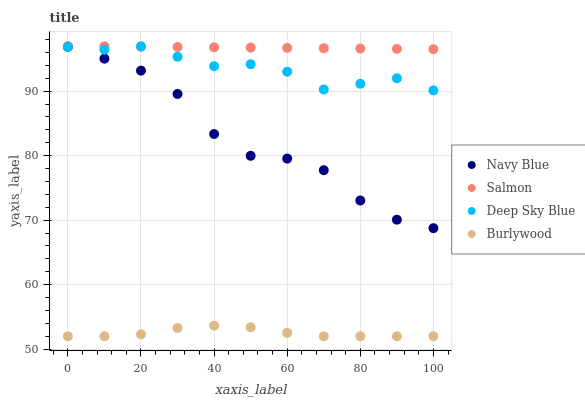Does Burlywood have the minimum area under the curve?
Answer yes or no. Yes. Does Salmon have the maximum area under the curve?
Answer yes or no. Yes. Does Navy Blue have the minimum area under the curve?
Answer yes or no. No. Does Navy Blue have the maximum area under the curve?
Answer yes or no. No. Is Salmon the smoothest?
Answer yes or no. Yes. Is Navy Blue the roughest?
Answer yes or no. Yes. Is Navy Blue the smoothest?
Answer yes or no. No. Is Salmon the roughest?
Answer yes or no. No. Does Burlywood have the lowest value?
Answer yes or no. Yes. Does Navy Blue have the lowest value?
Answer yes or no. No. Does Salmon have the highest value?
Answer yes or no. Yes. Does Navy Blue have the highest value?
Answer yes or no. No. Is Burlywood less than Deep Sky Blue?
Answer yes or no. Yes. Is Navy Blue greater than Burlywood?
Answer yes or no. Yes. Does Navy Blue intersect Deep Sky Blue?
Answer yes or no. Yes. Is Navy Blue less than Deep Sky Blue?
Answer yes or no. No. Is Navy Blue greater than Deep Sky Blue?
Answer yes or no. No. Does Burlywood intersect Deep Sky Blue?
Answer yes or no. No. 